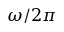Convert formula to latex. <formula><loc_0><loc_0><loc_500><loc_500>\omega / 2 \pi</formula> 